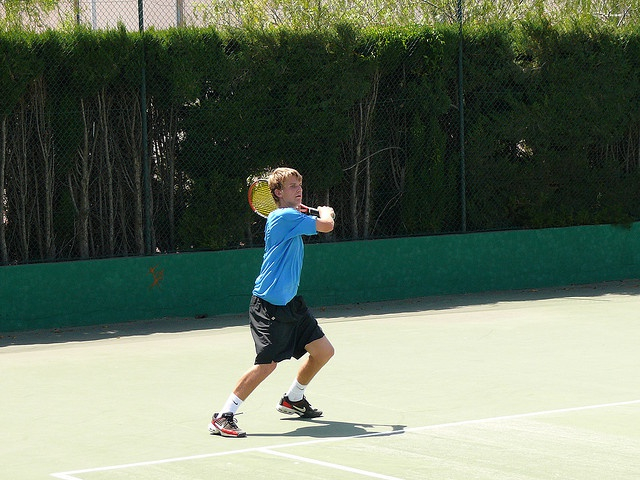Describe the objects in this image and their specific colors. I can see people in olive, black, gray, and ivory tones and tennis racket in olive, tan, and black tones in this image. 